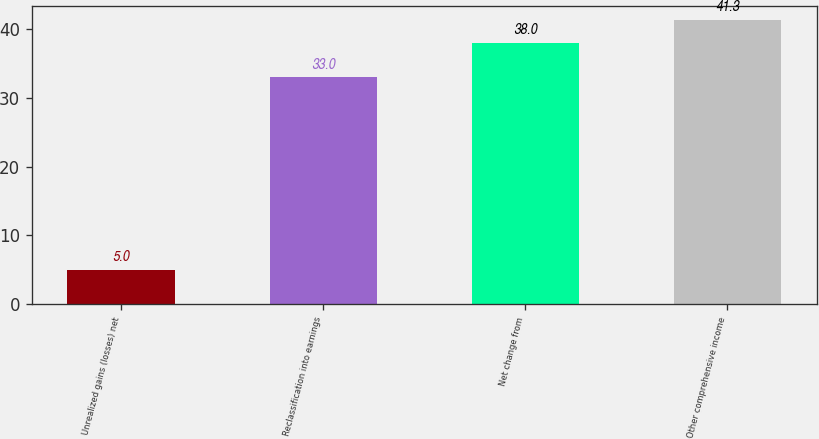<chart> <loc_0><loc_0><loc_500><loc_500><bar_chart><fcel>Unrealized gains (losses) net<fcel>Reclassification into earnings<fcel>Net change from<fcel>Other comprehensive income<nl><fcel>5<fcel>33<fcel>38<fcel>41.3<nl></chart> 